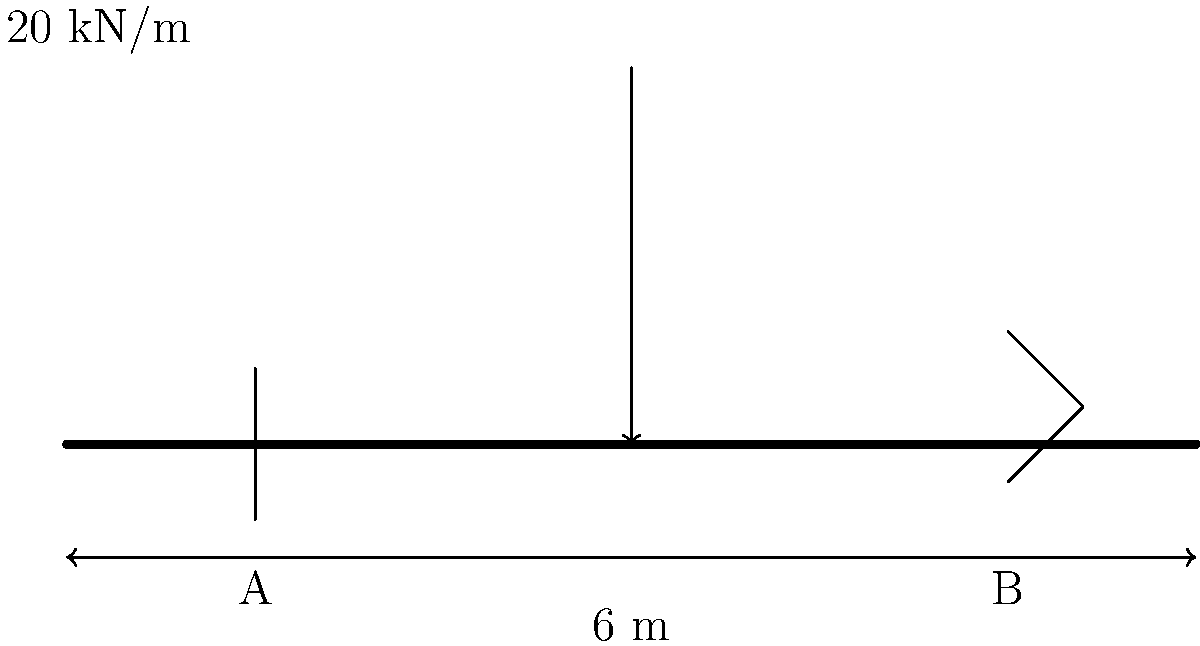As a full-stack developer integrating structural analysis into your software, you need to calculate the shear force distribution in a reinforced concrete beam. Consider a simply supported beam with a span of 6 m, subjected to a uniformly distributed load of 20 kN/m along its entire length. Determine the maximum shear force in the beam. To calculate the maximum shear force, we'll follow these steps:

1. Calculate the total load on the beam:
   $$ W = w \times L = 20 \text{ kN/m} \times 6 \text{ m} = 120 \text{ kN} $$

2. For a simply supported beam with a uniformly distributed load, the maximum shear force occurs at the supports and is equal to half of the total load:
   $$ V_{max} = \frac{W}{2} = \frac{120 \text{ kN}}{2} = 60 \text{ kN} $$

3. The shear force diagram for this beam would be linear, starting at +60 kN at the left support (A), decreasing to 0 at the midspan, and then increasing to -60 kN at the right support (B).

4. The shear force at any point x along the beam can be calculated using:
   $$ V(x) = \frac{wL}{2} - wx $$
   where w is the uniformly distributed load, L is the span length, and x is the distance from the left support.

5. To verify, we can check the shear force at midspan (x = 3 m):
   $$ V(3) = \frac{20 \times 6}{2} - 20 \times 3 = 60 - 60 = 0 \text{ kN} $$

Therefore, the maximum shear force in the beam is 60 kN, occurring at both supports.
Answer: 60 kN 